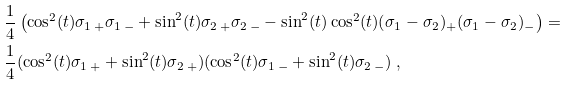<formula> <loc_0><loc_0><loc_500><loc_500>& \frac { 1 } { 4 } \left ( \cos ^ { 2 } ( t ) \sigma _ { 1 \, + } \sigma _ { 1 \, - } + \sin ^ { 2 } ( t ) \sigma _ { 2 \, + } \sigma _ { 2 \, - } - \sin ^ { 2 } ( t ) \cos ^ { 2 } ( t ) ( \sigma _ { 1 } - \sigma _ { 2 } ) _ { + } ( \sigma _ { 1 } - \sigma _ { 2 } ) _ { - } \right ) = \\ & \frac { 1 } { 4 } ( \cos ^ { 2 } ( t ) \sigma _ { 1 \, + } + \sin ^ { 2 } ( t ) \sigma _ { 2 \, + } ) ( \cos ^ { 2 } ( t ) \sigma _ { 1 \, - } + \sin ^ { 2 } ( t ) \sigma _ { 2 \, - } ) \ ,</formula> 